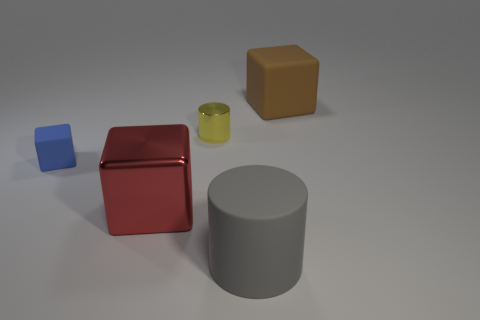Subtract all brown rubber blocks. How many blocks are left? 2 Add 1 big cubes. How many objects exist? 6 Subtract all red cubes. How many cubes are left? 2 Add 5 large cyan rubber cubes. How many large cyan rubber cubes exist? 5 Subtract 1 gray cylinders. How many objects are left? 4 Subtract all cylinders. How many objects are left? 3 Subtract 1 blocks. How many blocks are left? 2 Subtract all purple cubes. Subtract all yellow cylinders. How many cubes are left? 3 Subtract all green cubes. How many blue cylinders are left? 0 Subtract all red blocks. Subtract all metal objects. How many objects are left? 2 